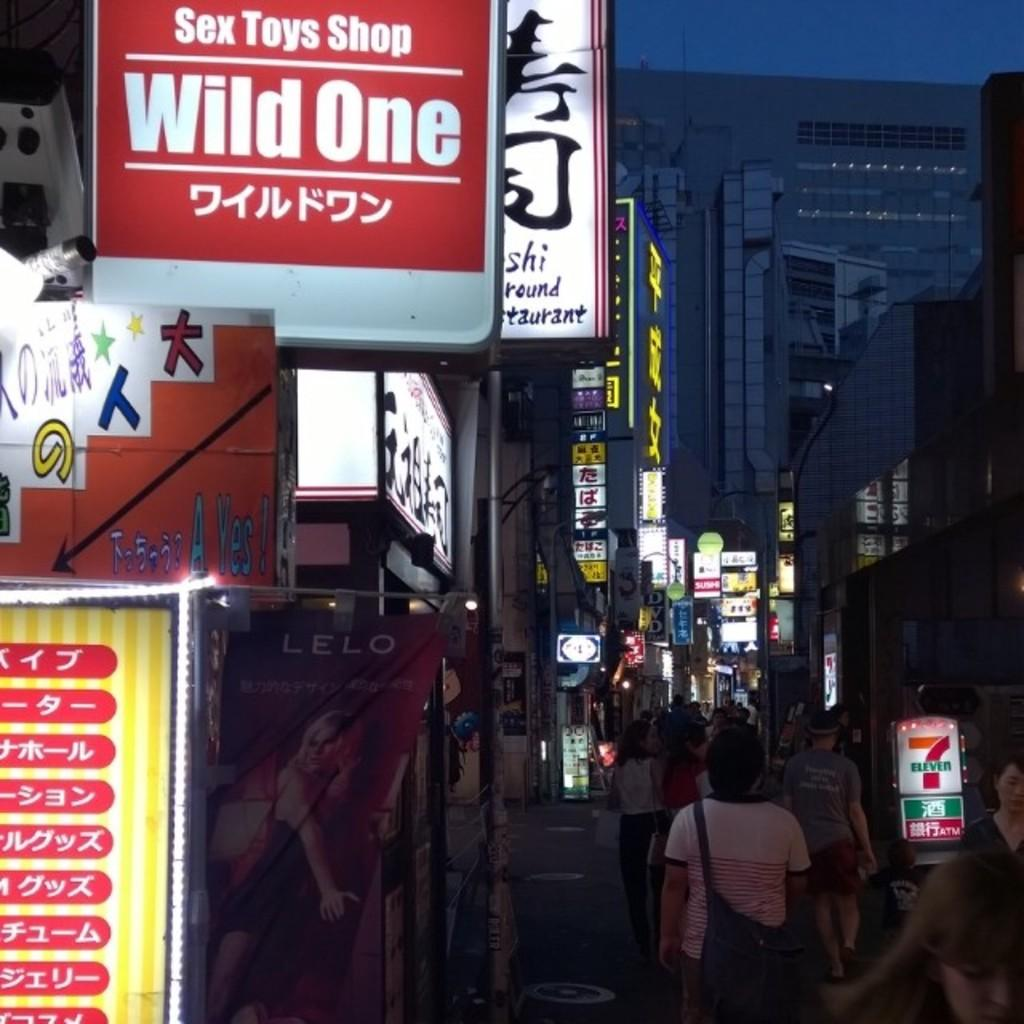<image>
Share a concise interpretation of the image provided. A shop called Wild One has a red sign with some Japanese on it. 